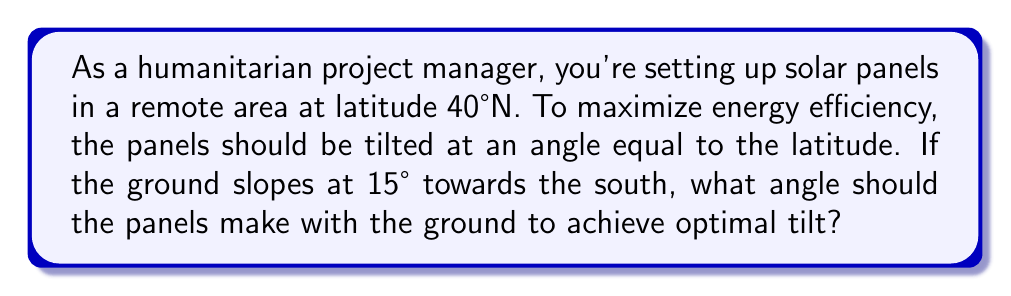What is the answer to this math problem? Let's approach this step-by-step:

1) The optimal tilt angle for solar panels is generally equal to the latitude of the location. In this case, it's 40°.

2) We need to find the angle between the panels and the ground. Let's call this angle $\theta$.

3) We can visualize this as a right-angled triangle:

[asy]
import geometry;

size(200);

pair A=(0,0), B=(5,0), C=(5,4);
draw(A--B--C--A);

label("Ground", (2.5,0), S);
label("Panel", (5,2), E);
label("40°", (0,0), NW);
label("$\theta$", (5,0), NE);
label("15°", (5,4), NW);

draw(arc(A,0.8,0,40),Arrow);
draw(arc(B,0.8,90,75),Arrow);
draw(arc(C,0.8,270-40,270),Arrow);
[/asy]

4) From the diagram, we can see that the angle between the panel and the horizontal (40°) is the sum of the ground slope (15°) and the angle we're looking for ($\theta$):

   $40° = 15° + \theta$

5) Solving for $\theta$:

   $\theta = 40° - 15° = 25°$

Therefore, the panels should be tilted at a 25° angle relative to the ground to achieve the optimal 40° tilt from horizontal.
Answer: 25° 